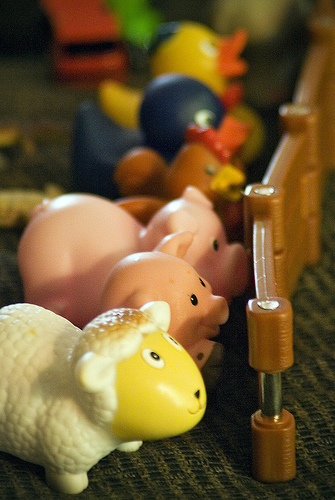<image>
Is there a nail on the fence? Yes. Looking at the image, I can see the nail is positioned on top of the fence, with the fence providing support. Is there a mat under the toy? Yes. The mat is positioned underneath the toy, with the toy above it in the vertical space. Is the pig under the sheep? No. The pig is not positioned under the sheep. The vertical relationship between these objects is different. 